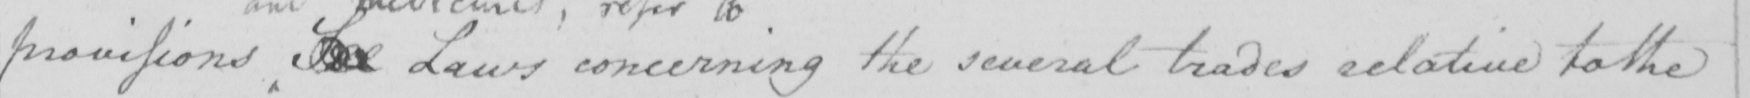Please transcribe the handwritten text in this image. provisions See Laws concerning the several trades relative to the 